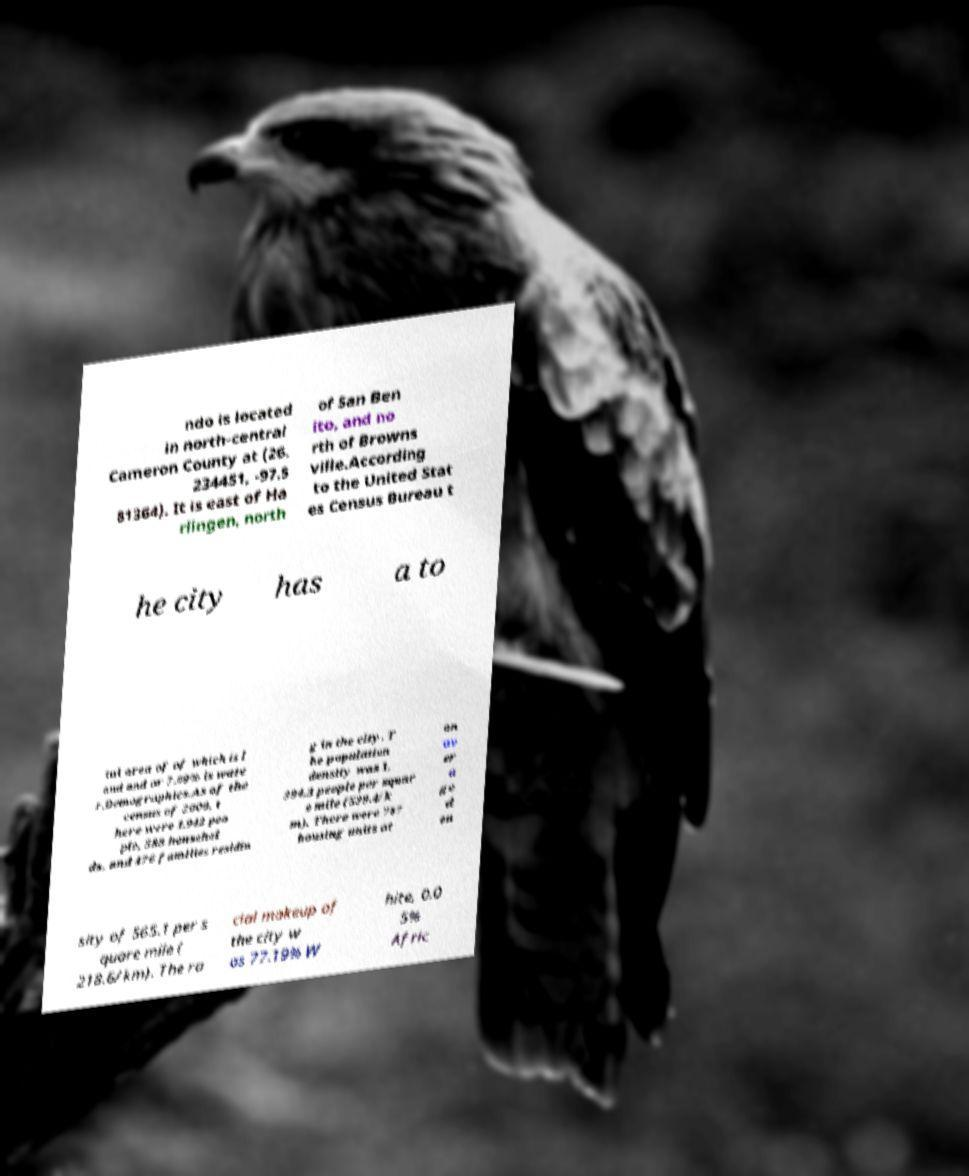Could you assist in decoding the text presented in this image and type it out clearly? ndo is located in north-central Cameron County at (26. 234451, -97.5 81364). It is east of Ha rlingen, north of San Ben ito, and no rth of Browns ville.According to the United Stat es Census Bureau t he city has a to tal area of of which is l and and or 7.09% is wate r.Demographics.As of the census of 2000, t here were 1,942 peo ple, 588 househol ds, and 476 families residin g in the city. T he population density was 1, 394.3 people per squar e mile (539.4/k m). There were 787 housing units at an av er a ge d en sity of 565.1 per s quare mile ( 218.6/km). The ra cial makeup of the city w as 77.19% W hite, 0.0 5% Afric 